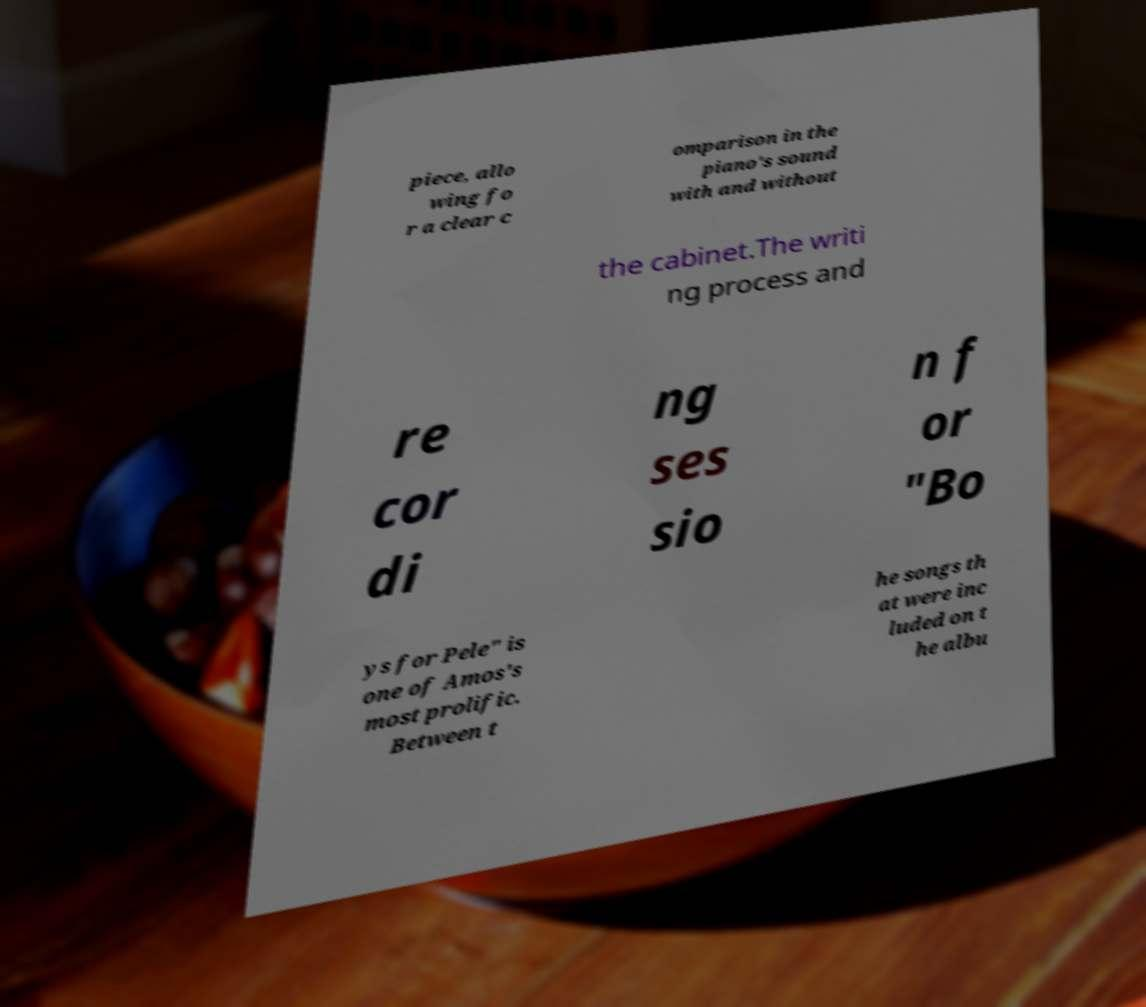There's text embedded in this image that I need extracted. Can you transcribe it verbatim? piece, allo wing fo r a clear c omparison in the piano's sound with and without the cabinet.The writi ng process and re cor di ng ses sio n f or "Bo ys for Pele" is one of Amos's most prolific. Between t he songs th at were inc luded on t he albu 